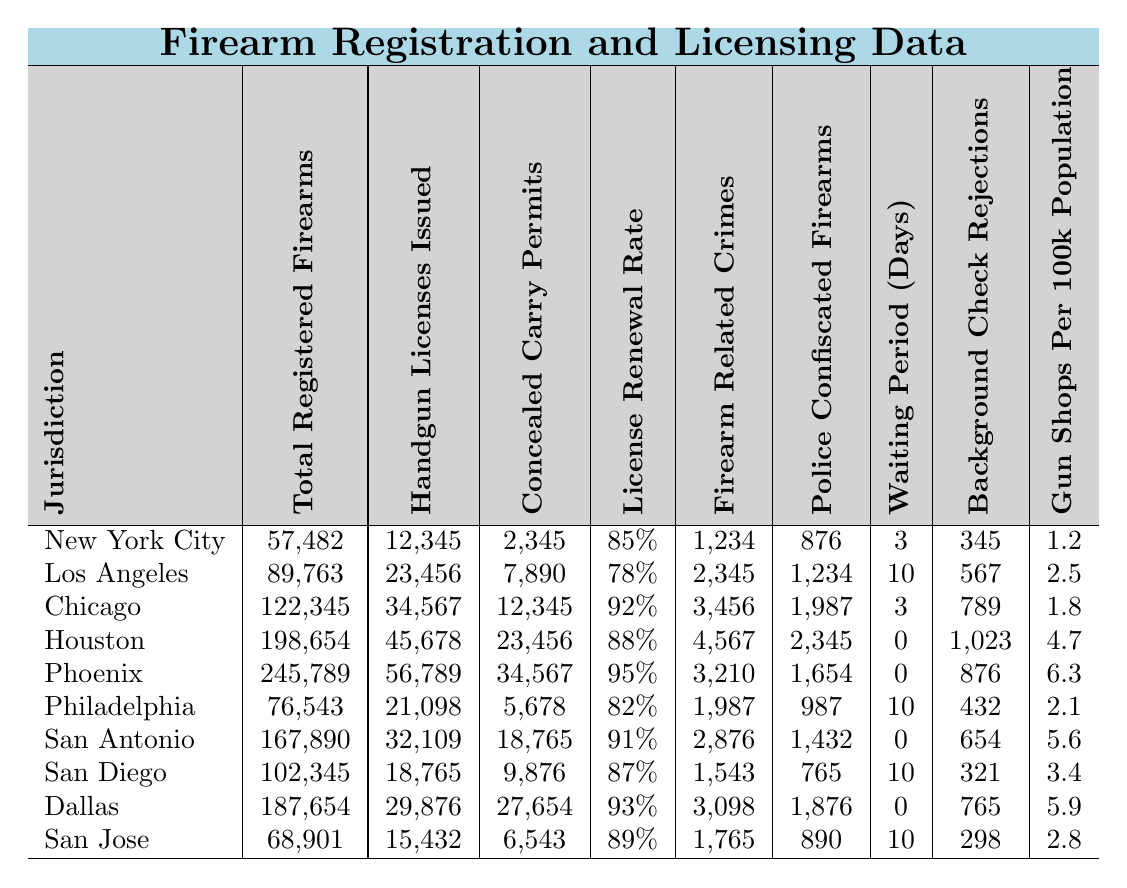What jurisdiction has the highest number of total registered firearms? According to the table, Phoenix has the highest number of total registered firearms with 245,789.
Answer: Phoenix How many concealed carry permits were issued in Los Angeles? The table states that Los Angeles issued 7,890 concealed carry permits.
Answer: 7,890 What is the license renewal rate for Chicago? The license renewal rate for Chicago is 92%, as indicated in the table.
Answer: 92% Which jurisdiction has the lowest number of police confiscated firearms? San Diego has the lowest number of police confiscated firearms with a count of 765.
Answer: San Diego What is the average waiting period for firearm registration across all jurisdictions? The total waiting period across all jurisdictions is (3 + 10 + 3 + 0 + 0 + 10 + 0 + 10 + 0 + 10) = 56 days, and there are 10 jurisdictions, so the average is 56/10 = 5.6 days.
Answer: 5.6 days Is there a jurisdiction with a license renewal rate of 95%? Yes, Phoenix has a license renewal rate of 95%.
Answer: Yes How many firearms related crimes were reported in Houston, and how does this compare to the median for all jurisdictions? Houston reported 4,567 firearm related crimes. The median across the jurisdictions is 2,876 (when organized, the median of the sorted list is (2,876 + 3,210)/2 from the 5th and 6th entries = 2,991). Thus, Houston's number is above the median.
Answer: Above the median What is the jurisdiction with the highest background check rejections? Houston has the highest background check rejections with a total of 1,023.
Answer: Houston Calculate the difference in total registered firearms between San Antonio and San Jose. San Antonio has 167,890 total registered firearms and San Jose has 68,901. The difference is 167,890 - 68,901 = 98,989.
Answer: 98,989 Which jurisdiction has the highest number of gun shops per 100k population? Phoenix has the highest number with 6.3 gun shops per 100k population as per the table.
Answer: Phoenix 